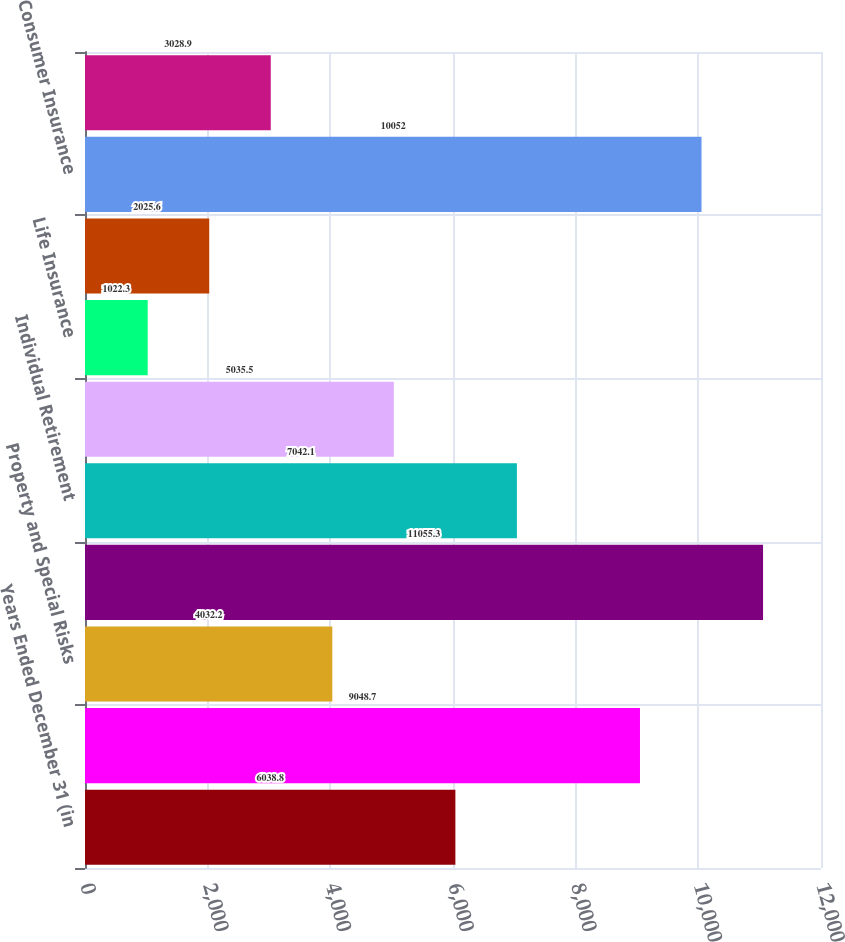Convert chart to OTSL. <chart><loc_0><loc_0><loc_500><loc_500><bar_chart><fcel>Years Ended December 31 (in<fcel>Liability and Financial Lines<fcel>Property and Special Risks<fcel>Commercial Insurance<fcel>Individual Retirement<fcel>Group Retirement<fcel>Life Insurance<fcel>Personal Insurance<fcel>Consumer Insurance<fcel>Other Operations<nl><fcel>6038.8<fcel>9048.7<fcel>4032.2<fcel>11055.3<fcel>7042.1<fcel>5035.5<fcel>1022.3<fcel>2025.6<fcel>10052<fcel>3028.9<nl></chart> 